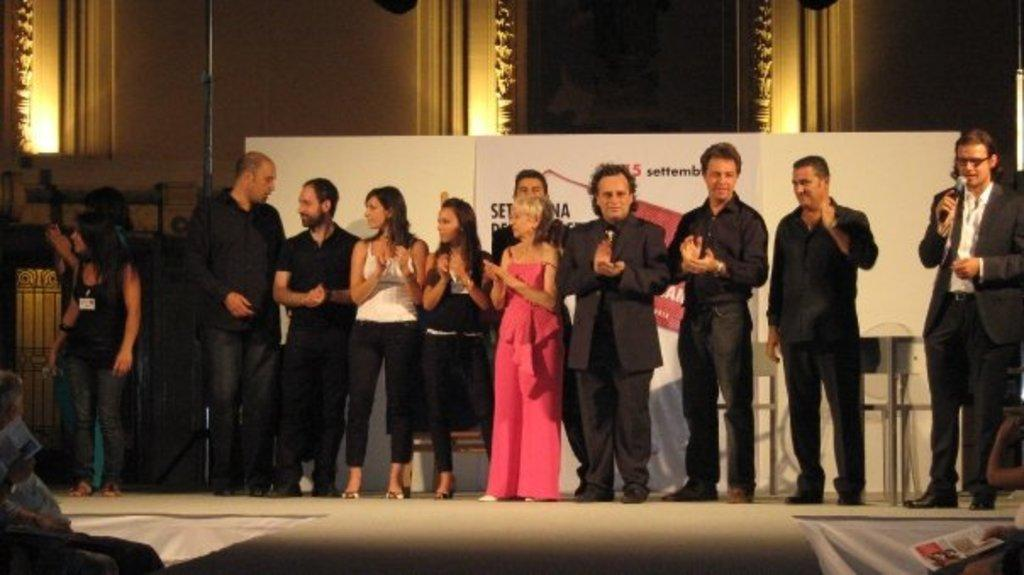What is happening on the stage in the image? There are many people standing on the stage. Can you describe the person on the right side of the stage? The person on the right side is holding a microphone. What is the person on the right side doing? The person on the right side is speaking about something. What type of place is the person on the right side of the stage trying to get the audience's attention to? The image does not provide information about a specific place that the person is trying to get the audience's attention to. 